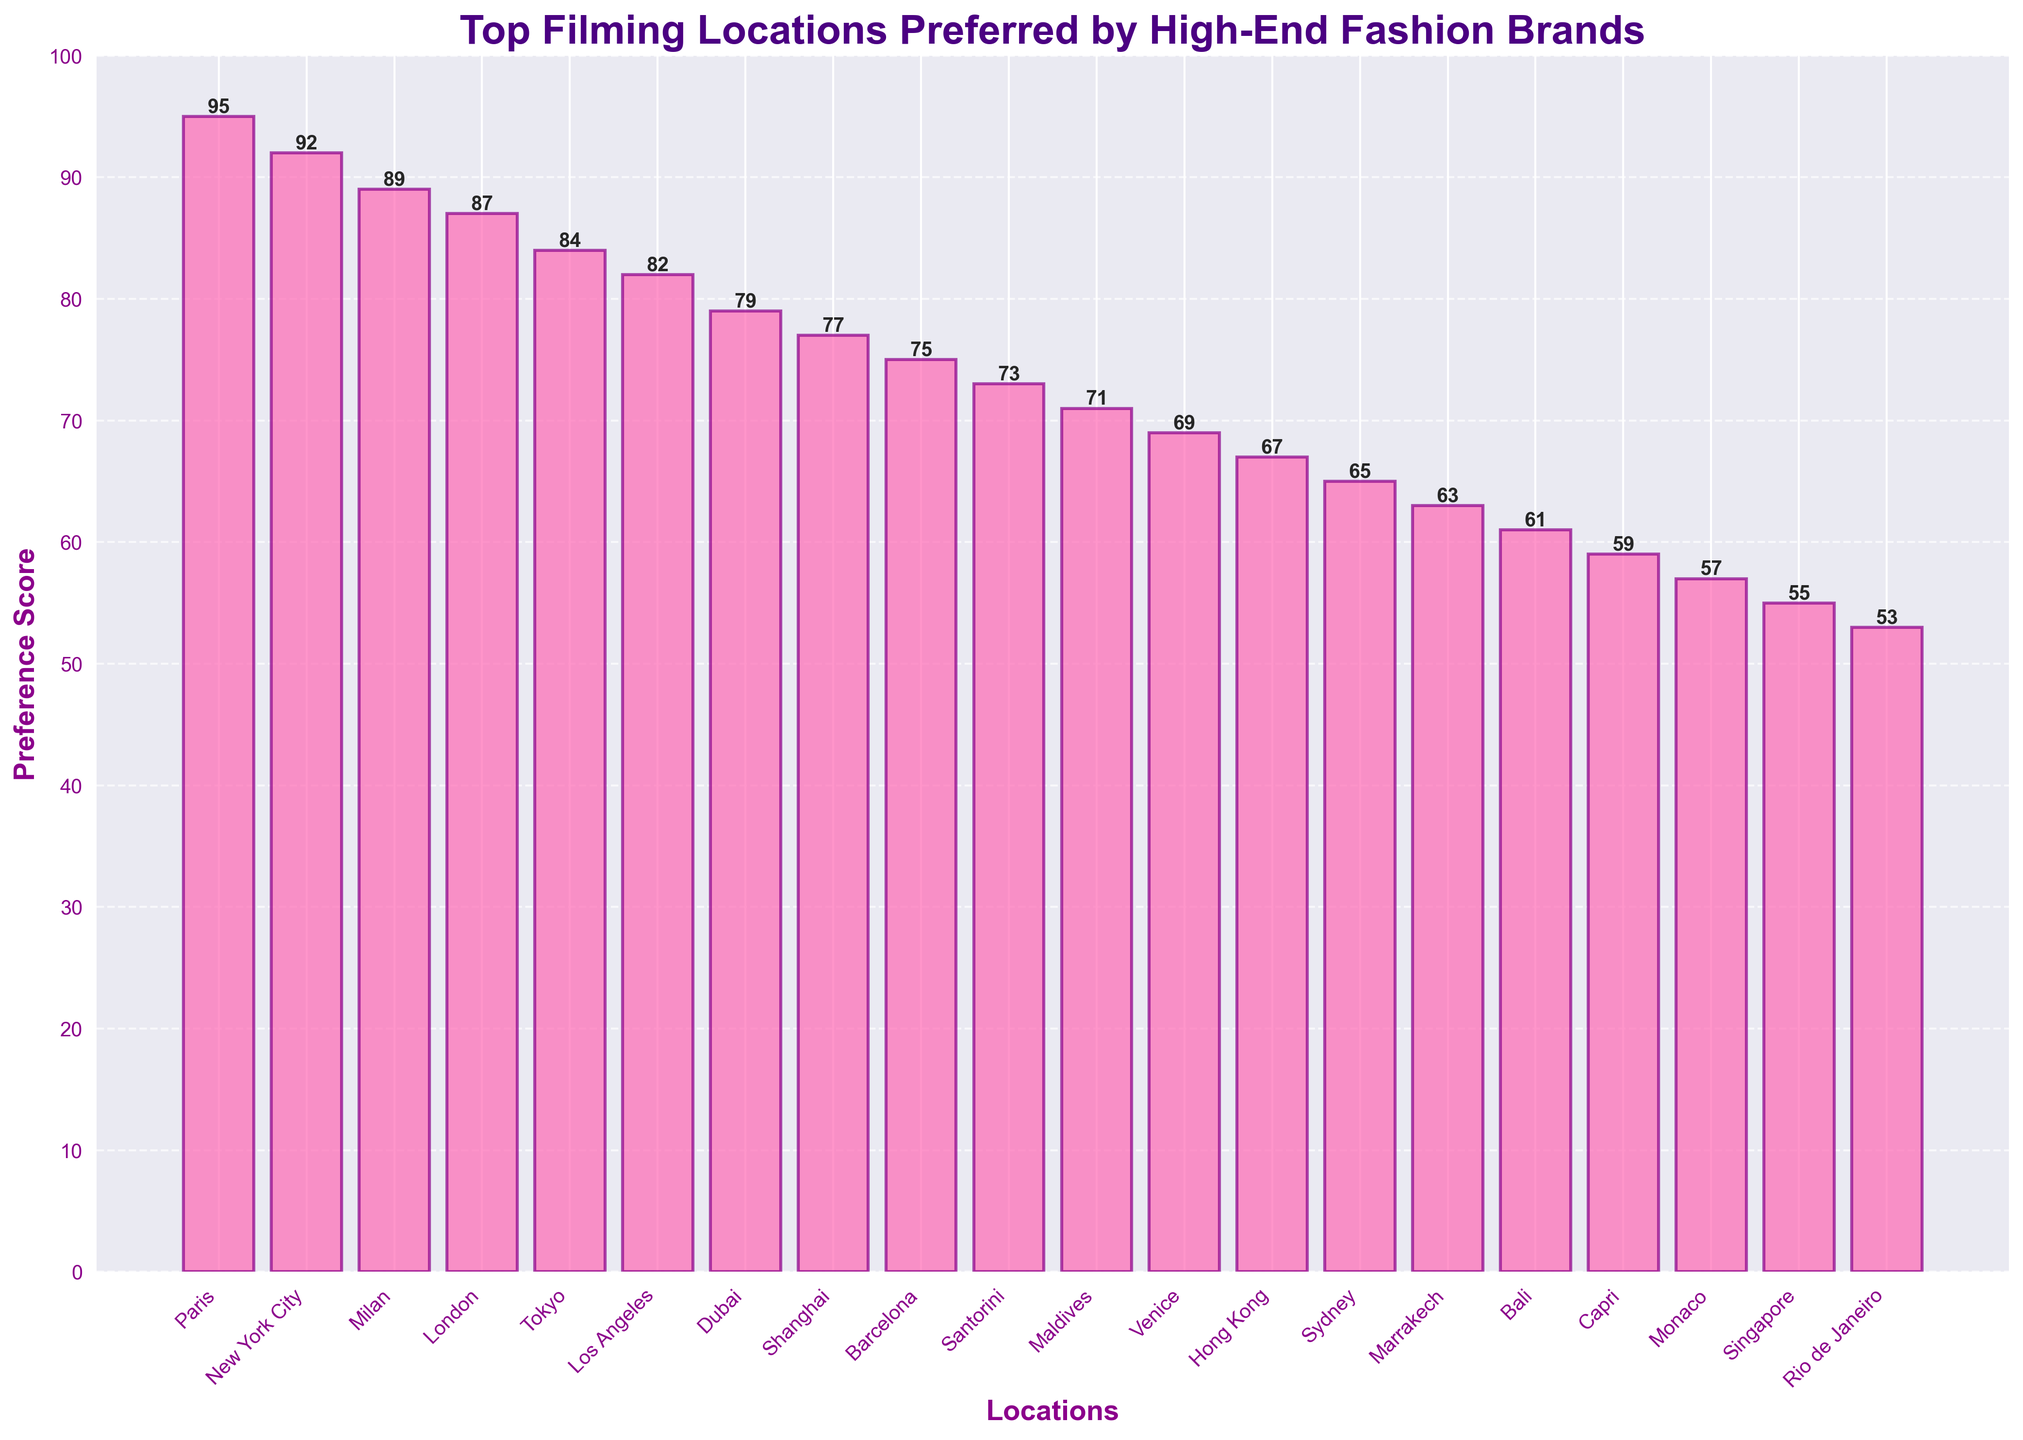What is the most preferred filming location for high-end fashion brands? The bar representing Paris is the tallest among all the bars on the plot, indicating it has the highest preference score.
Answer: Paris Which filming location has the lowest preference score? The bar representing Rio de Janeiro is the shortest among all the bars, indicating it has the lowest preference score.
Answer: Rio de Janeiro How many filming locations have a preference score above 80? Observing the bar plot, we see that the locations with preference scores above 80: Paris, New York City, Milan, London, Tokyo, and Los Angeles, which totals to 6 locations.
Answer: 6 What is the combined preference score of the top three locations? The top three locations are Paris (95), New York City (92), and Milan (89). Adding these scores: 95 + 92 + 89 = 276
Answer: 276 Which location is more preferred: Tokyo or Dubai? By comparing the heights of the bars, Tokyo has a preference score of 84 while Dubai has 79, indicating Tokyo is more preferred.
Answer: Tokyo How much higher is the preference score of New York City compared to Sydney? New York City's preference score is 92, and Sydney's score is 65. The difference is calculated as 92 - 65 = 27.
Answer: 27 Is the preference score for London greater than, less than, or equal to the preference score of Barcelona? Comparing both bars, London has a preference score of 87 while Barcelona has 75, indicating London's score is greater.
Answer: Greater What is the average preference score of the top 5 locations? The top 5 locations and their scores are Paris (95), New York City (92), Milan (89), London (87), and Tokyo (84). The average is calculated as (95 + 92 + 89 + 87 + 84) / 5 = 89.4
Answer: 89.4 Are there more locations with a preference score above 70 or below 70? Counting the bars, there are 13 locations with scores above 70 and 7 locations below 70. Therefore, there are more locations above 70.
Answer: Above 70 Which location has a preference score closest to the median preference score of all locations? Listing all scores in ascending order: 53, 55, 57, 59, 61, 63, 65, 67, 69, 71, 73, 75, 77, 79, 82, 84, 87, 89, 92, 95. The median is the average of the 10th and 11th values: (71+73)/2 = 72. The location closest to 72 is Santorini with a score of 73.
Answer: Santorini 